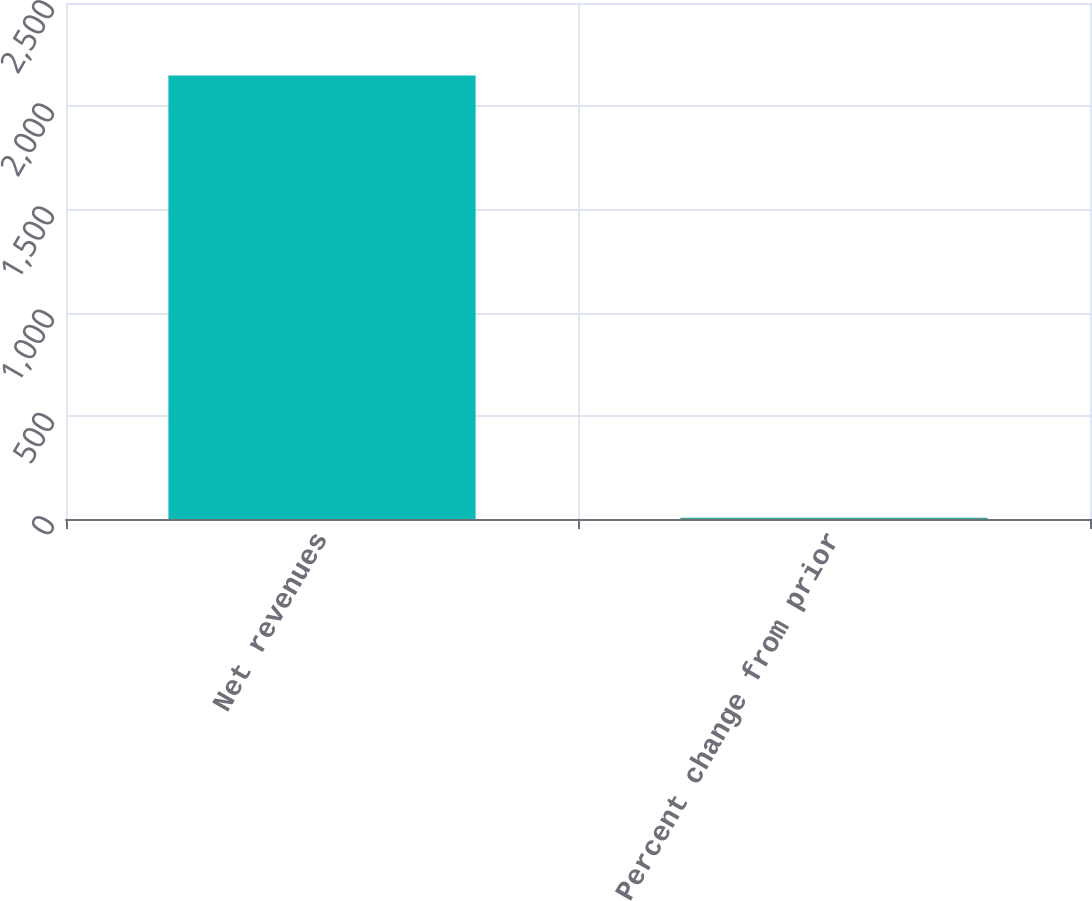Convert chart. <chart><loc_0><loc_0><loc_500><loc_500><bar_chart><fcel>Net revenues<fcel>Percent change from prior<nl><fcel>2149<fcel>6<nl></chart> 